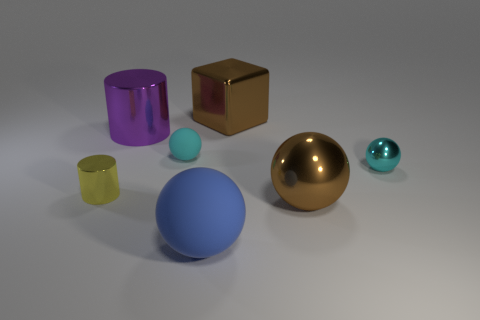Subtract all large shiny balls. How many balls are left? 3 Subtract 2 balls. How many balls are left? 2 Subtract all brown balls. How many balls are left? 3 Subtract all red spheres. Subtract all brown blocks. How many spheres are left? 4 Add 1 purple metallic cylinders. How many objects exist? 8 Subtract all cylinders. How many objects are left? 5 Add 3 brown metallic cubes. How many brown metallic cubes exist? 4 Subtract 1 brown cubes. How many objects are left? 6 Subtract all small shiny spheres. Subtract all brown balls. How many objects are left? 5 Add 1 blue objects. How many blue objects are left? 2 